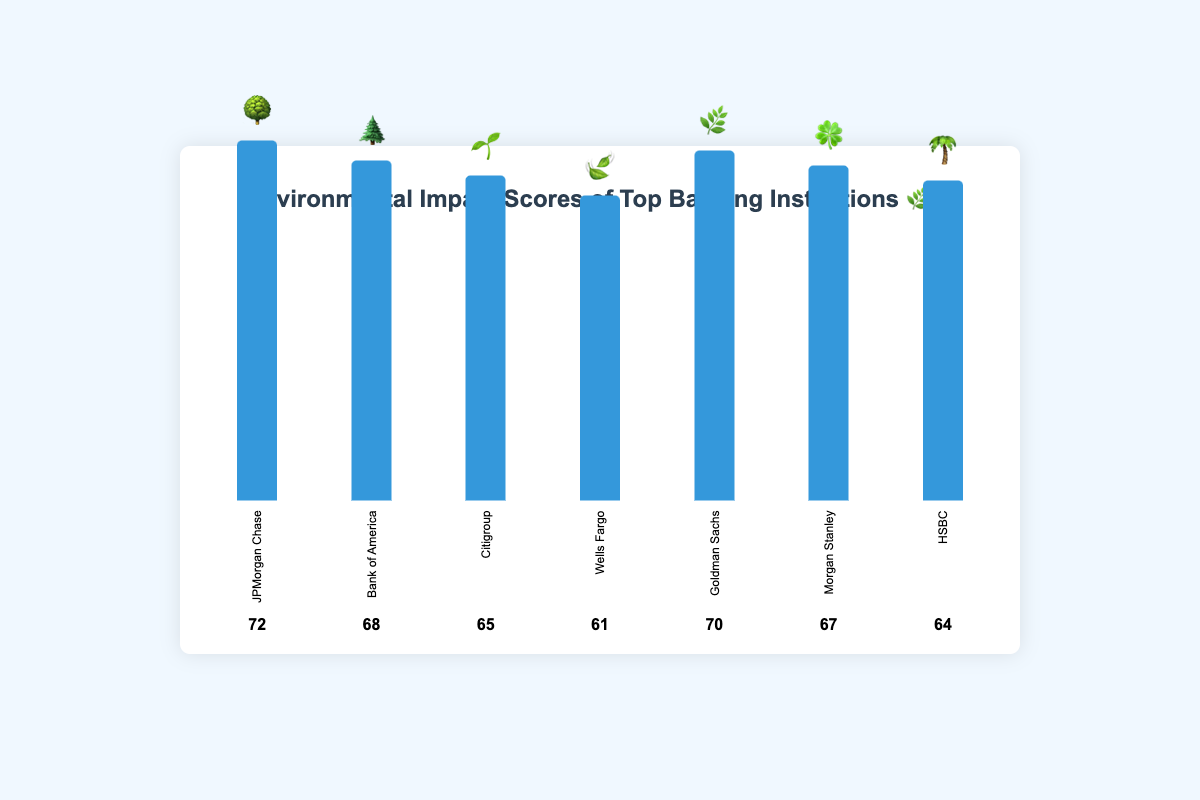Which bank has the highest environmental impact score? By observing the height of the bars, JPMorgan Chase has the highest bar and a score of 72.
Answer: JPMorgan Chase What is the environmental impact score of Goldman Sachs? The bar labeled Goldman Sachs has a score next to it, which is 70.
Answer: 70 How many banks have an environmental impact score higher than 65? By counting the banks with scores greater than 65: JPMorgan Chase (72), Bank of America (68), Goldman Sachs (70), and Morgan Stanley (67).
Answer: 4 Which bank has the lowest environmental impact score, and what is the score? The shortest bar represents HSBC, with a score of 64.
Answer: HSBC, 64 What is the difference in environmental impact scores between Bank of America and Wells Fargo? Bank of America's score is 68 and Wells Fargo's score is 61. The difference is 68 - 61.
Answer: 7 Arrange the banks in descending order of their environmental impact scores. From the highest score to the lowest: JPMorgan Chase (72), Goldman Sachs (70), Bank of America (68), Morgan Stanley (67), Citigroup (65), HSBC (64), Wells Fargo (61).
Answer: JPMorgan Chase, Goldman Sachs, Bank of America, Morgan Stanley, Citigroup, HSBC, Wells Fargo What is the average environmental impact score of all the banks listed? Sum the scores of all banks: 72 + 68 + 65 + 61 + 70 + 67 + 64 = 467. There are 7 banks, so the average is 467 / 7.
Answer: 66.71 Compare the environmental impact scores of Citigroup and Morgan Stanley. Which one is higher, and by how much? Citigroup has a score of 65 and Morgan Stanley has a score of 67. Morgan Stanley's score is higher by 67 - 65.
Answer: Morgan Stanley, 2 Which bank's score is represented by the 🍀 emoji? The 🍀 emoji corresponds to the bar for Morgan Stanley.
Answer: Morgan Stanley 